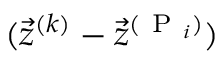<formula> <loc_0><loc_0><loc_500><loc_500>( \vec { z } ^ { ( k ) } - \vec { z } ^ { ( P _ { i } ) } )</formula> 